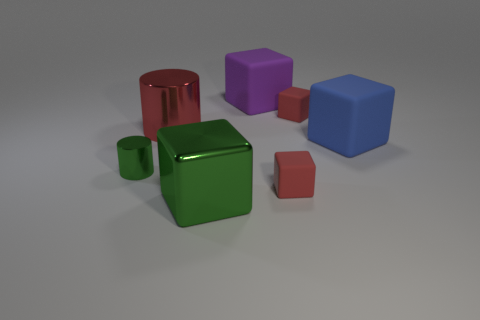How many purple cubes have the same size as the green cube?
Offer a very short reply. 1. There is a blue block that is the same material as the large purple cube; what size is it?
Offer a very short reply. Large. How many other purple objects have the same shape as the purple object?
Make the answer very short. 0. What number of red metallic cylinders are there?
Your answer should be very brief. 1. There is a small object to the left of the large green metal object; is its shape the same as the large blue matte object?
Make the answer very short. No. There is a red cylinder that is the same size as the blue rubber thing; what is it made of?
Give a very brief answer. Metal. Are there any small yellow things that have the same material as the large green block?
Your answer should be very brief. No. Do the tiny green thing and the large matte thing that is in front of the large purple cube have the same shape?
Your answer should be compact. No. What number of green things are to the right of the large metal cylinder and on the left side of the shiny block?
Give a very brief answer. 0. Are the small green thing and the red cube behind the large blue matte block made of the same material?
Make the answer very short. No. 